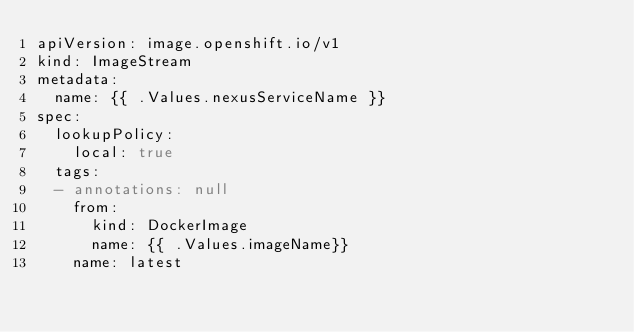Convert code to text. <code><loc_0><loc_0><loc_500><loc_500><_YAML_>apiVersion: image.openshift.io/v1
kind: ImageStream
metadata:
  name: {{ .Values.nexusServiceName }}
spec:
  lookupPolicy:
    local: true
  tags:
  - annotations: null
    from:
      kind: DockerImage
      name: {{ .Values.imageName}}
    name: latest</code> 